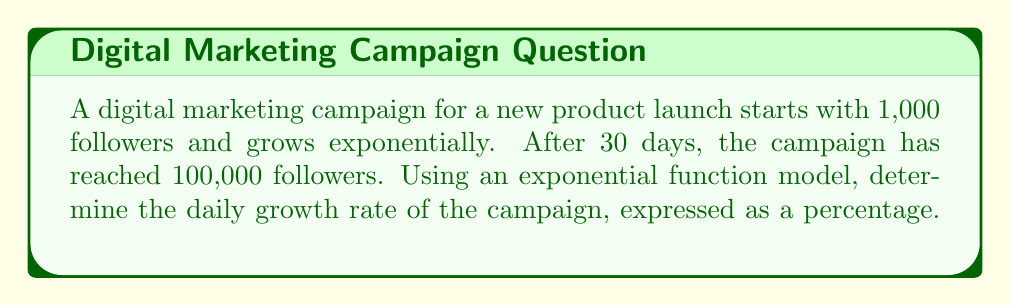Teach me how to tackle this problem. Let's approach this step-by-step:

1) The general form of an exponential function is:

   $$A(t) = A_0 \cdot r^t$$

   Where $A(t)$ is the amount at time $t$, $A_0$ is the initial amount, $r$ is the growth factor, and $t$ is the time.

2) We know:
   - Initial followers: $A_0 = 1,000$
   - Final followers: $A(30) = 100,000$
   - Time period: $t = 30$ days

3) Let's plug these into our equation:

   $$100,000 = 1,000 \cdot r^{30}$$

4) Simplify:

   $$100 = r^{30}$$

5) Take the 30th root of both sides:

   $$\sqrt[30]{100} = r$$

6) Calculate:

   $$r \approx 1.1612$$

7) To convert this to a percentage growth rate, subtract 1 and multiply by 100:

   $$(1.1612 - 1) \times 100 \approx 16.12\%$$

Thus, the daily growth rate is approximately 16.12%.
Answer: 16.12% 